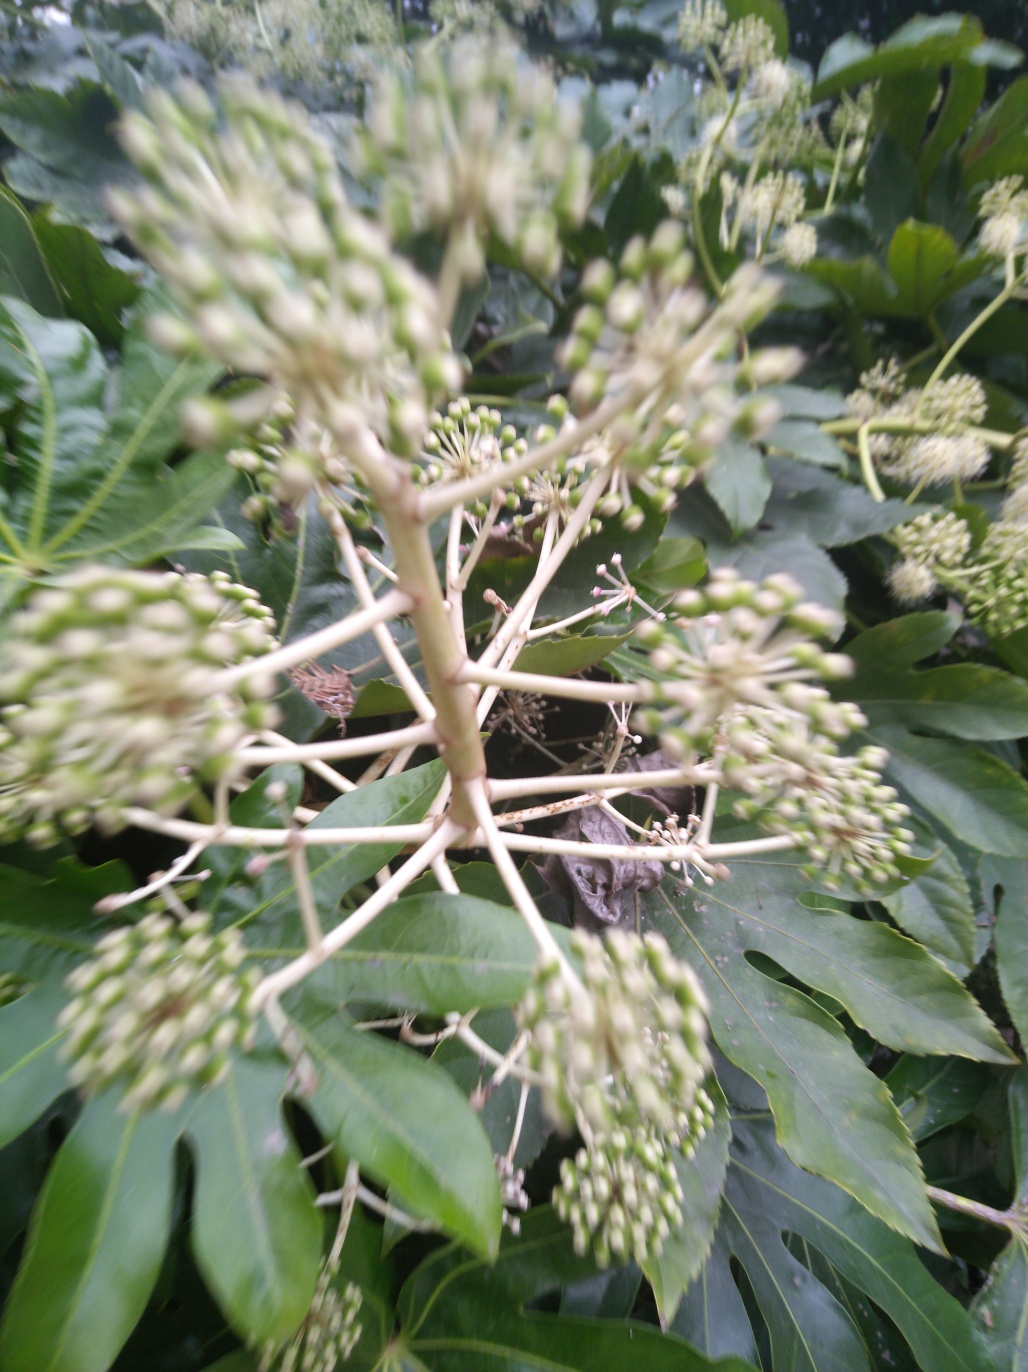What is the impact of motion blur on the image? Motion blur typically results in a loss of sharpness and detail, causing ghosting or streaking effects on moving subjects within the photograph. This can create a sense of movement and speed, but also detracts from the clarity of the image. In the provided image, you can clearly see the ghosting around the plant, indicating that either the camera or the subject moved during the exposure. 